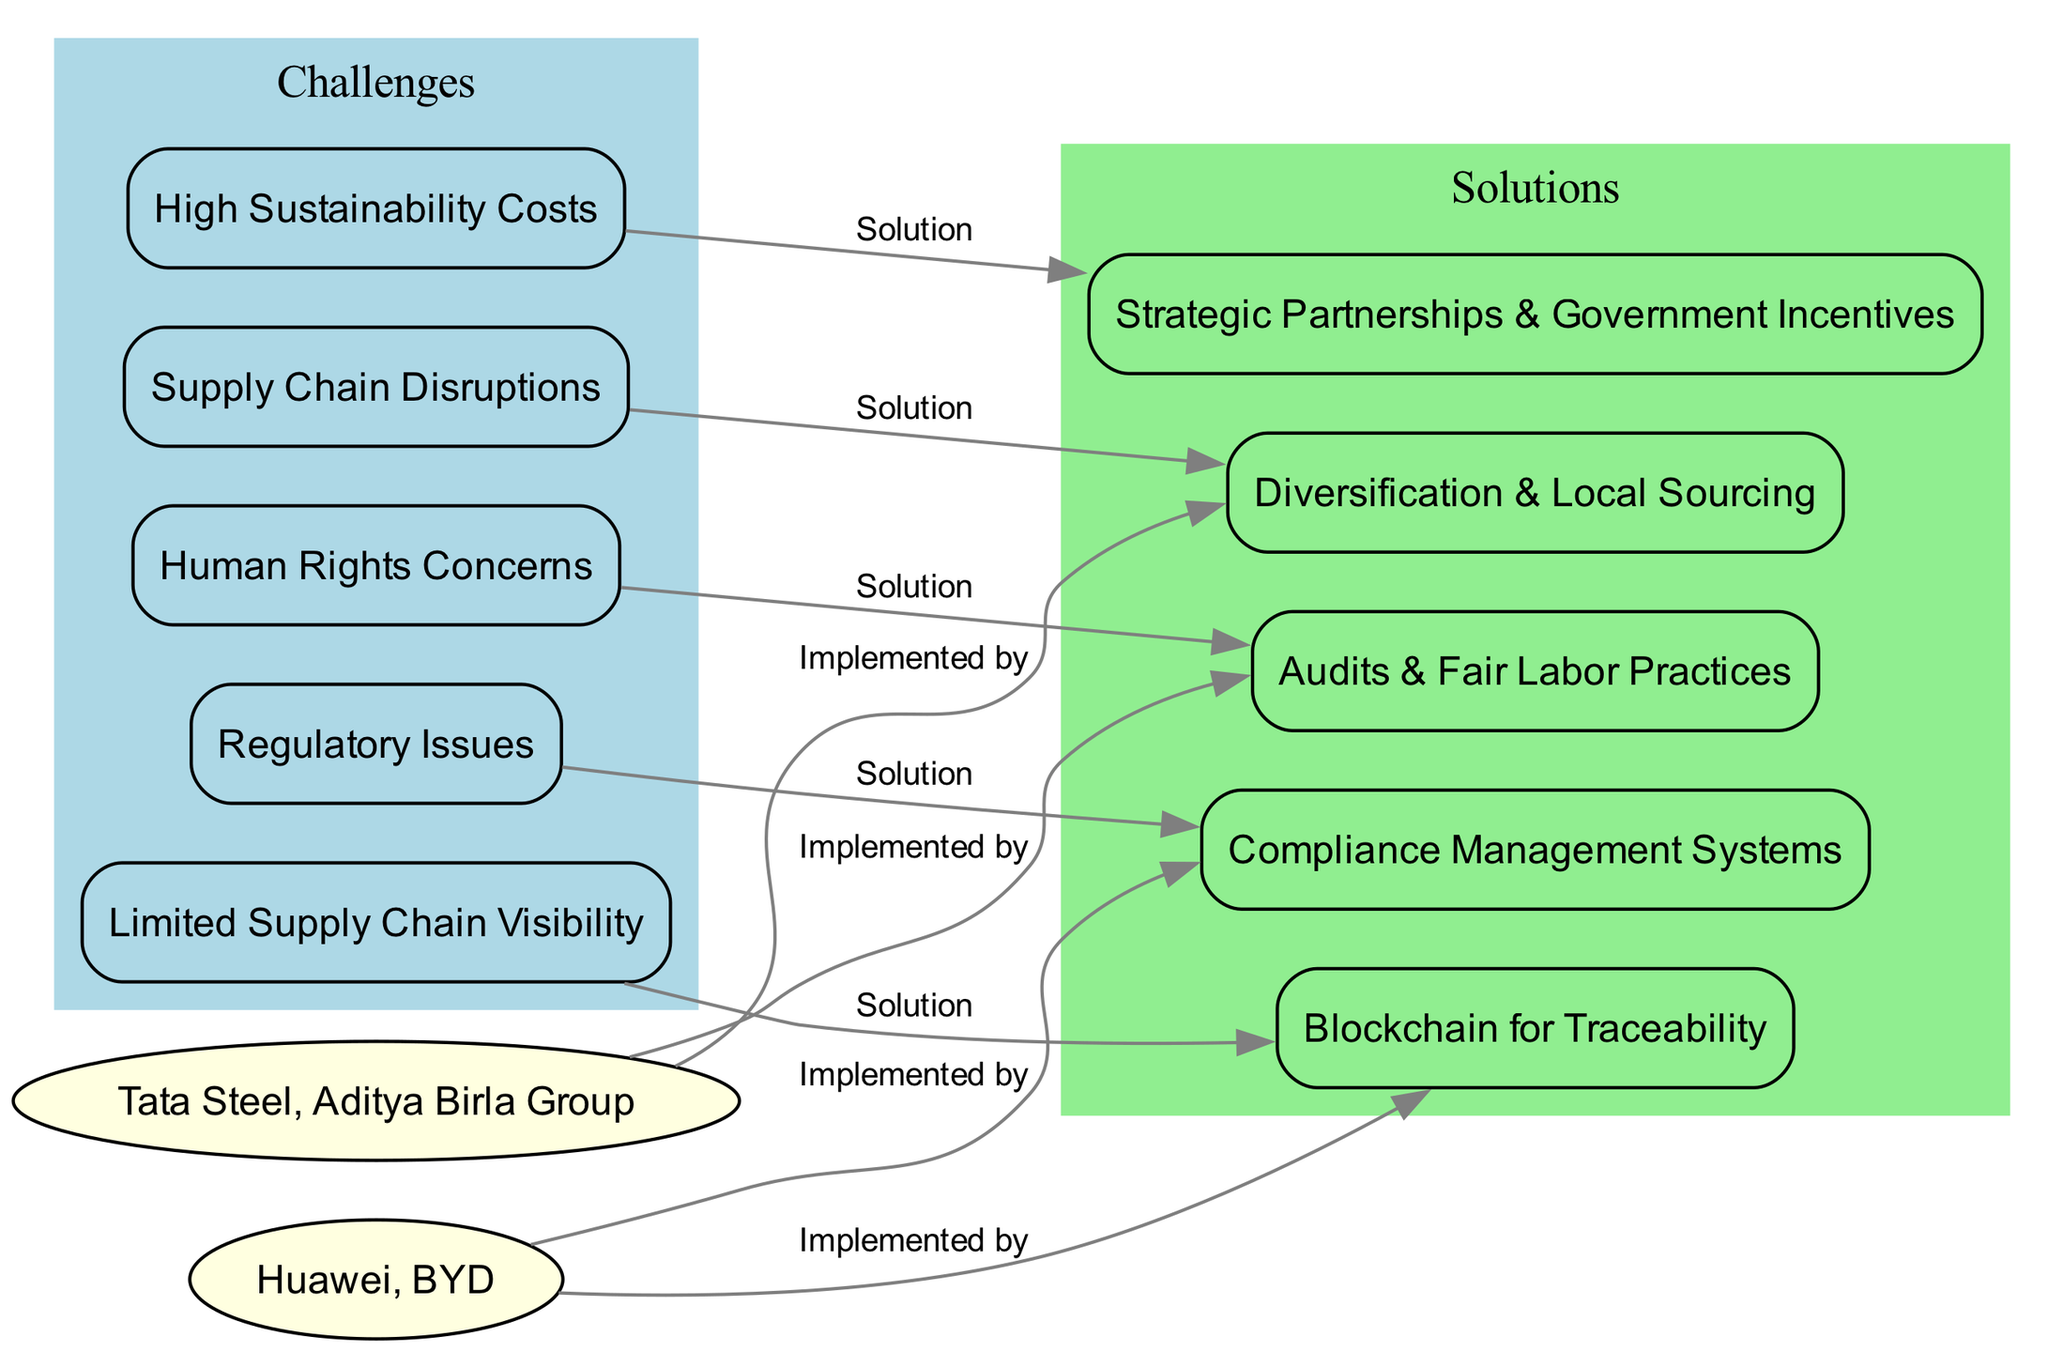What is one of the challenges in sustainable sourcing? The diagram includes several nodes representing challenges, one of which is specifically labeled "Supply Chain Disruptions."
Answer: Supply Chain Disruptions How many challenges are listed in the diagram? By counting the nodes that start with "challenge_", we find five that are specifically identified in the diagram.
Answer: 5 What solution is associated with regulatory issues? The edges indicate that "Compliance Management Systems" is connected to "Regulatory Issues," illustrating it as the solution for that challenge.
Answer: Compliance Management Systems Which company is implementing the solution for human rights concerns? The diagram shows an edge from "key_indian_companies" to "solution_human_rights," indicating that at least one Indian company is engaged in this solution.
Answer: Tata Steel, Aditya Birla Group Which technology is suggested for limited supply chain visibility? The label associated with the solution for "Limited Supply Chain Visibility" in the diagram is "Blockchain for Traceability," which indicates the technology recommended.
Answer: Blockchain for Traceability Which Indian company has implemented diversification and local sourcing? The directed edge shows that Indian companies listed in "key_indian_companies" are implementing "Diversification & Local Sourcing," indicating their proactive approach to combat supply chain disruptions.
Answer: Tata Steel, Aditya Birla Group What is the relationship between high sustainability costs and solutions? The edge indicates that "High Sustainability Costs" is linked to "Strategic Partnerships & Government Incentives," showing that this is the solution to the identified challenge.
Answer: Strategic Partnerships & Government Incentives Which Chinese company addresses limited supply chain visibility? The diagram shows that "Huawei" is linked to the solution for "Limited Supply Chain Visibility" with a directed edge, demonstrating its efforts in addressing this challenge.
Answer: Huawei What color represents challenges in the diagram? Upon analyzing the coloring of the subgraphs, the blue color represents the challenges in the diagram, clearly differentiating them from the solutions.
Answer: Light Blue 